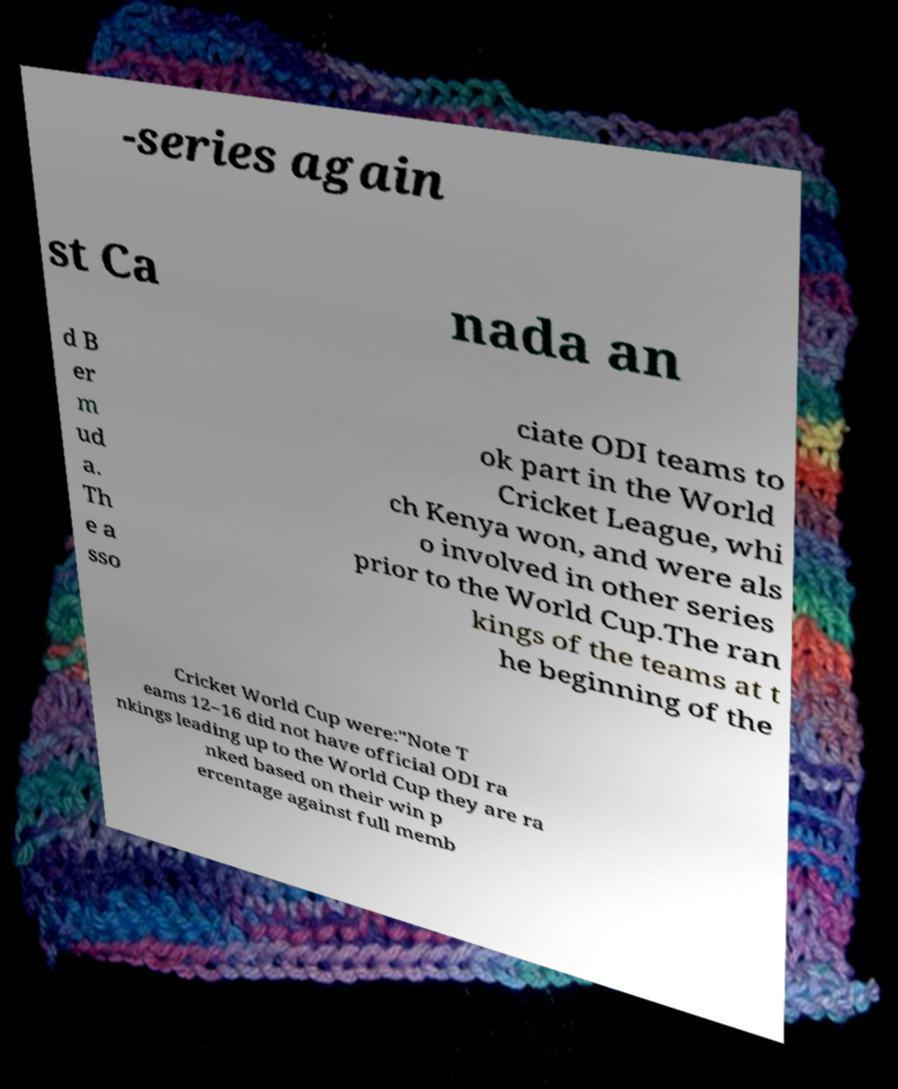Can you read and provide the text displayed in the image?This photo seems to have some interesting text. Can you extract and type it out for me? -series again st Ca nada an d B er m ud a. Th e a sso ciate ODI teams to ok part in the World Cricket League, whi ch Kenya won, and were als o involved in other series prior to the World Cup.The ran kings of the teams at t he beginning of the Cricket World Cup were:"Note T eams 12–16 did not have official ODI ra nkings leading up to the World Cup they are ra nked based on their win p ercentage against full memb 